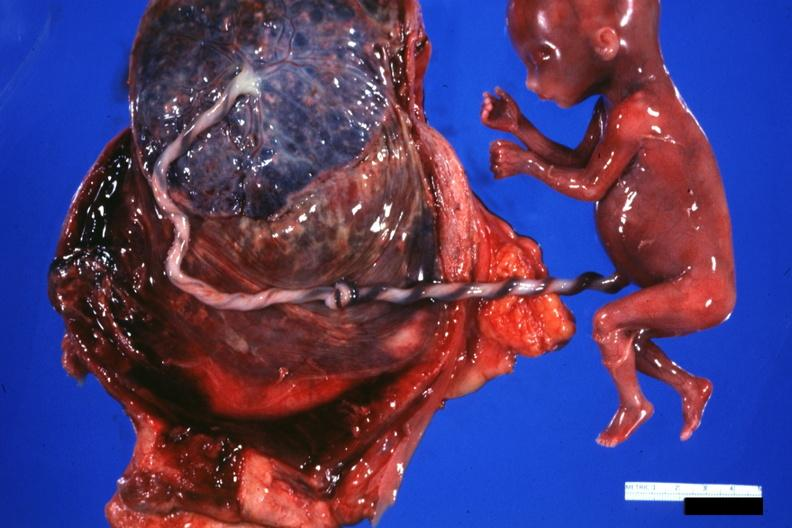s metastatic carcinoma oat cell present?
Answer the question using a single word or phrase. No 